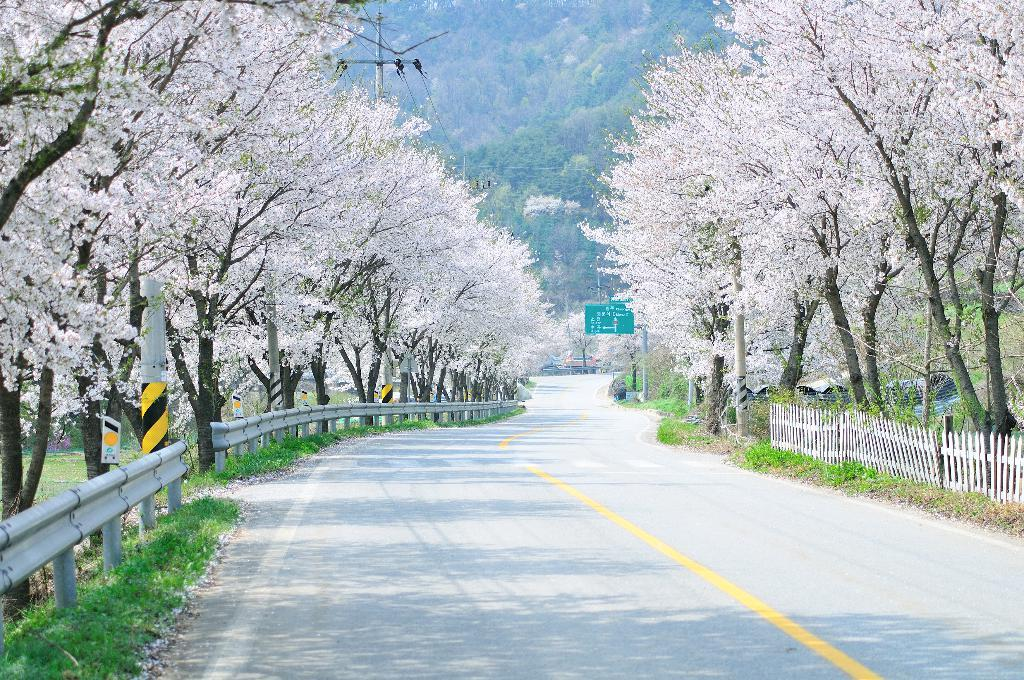What is the main feature of the image? There is a road in the image. What can be seen on either side of the road? There are trees on either side of the road. What is special about the trees? There are flowers on the trees. What can be seen in the distance in the image? There are mountains visible in the background of the image. Where is the crowd gathered in the image? There is no crowd present in the image. What type of soda is being served at the event in the image? There is no event or soda present in the image. 